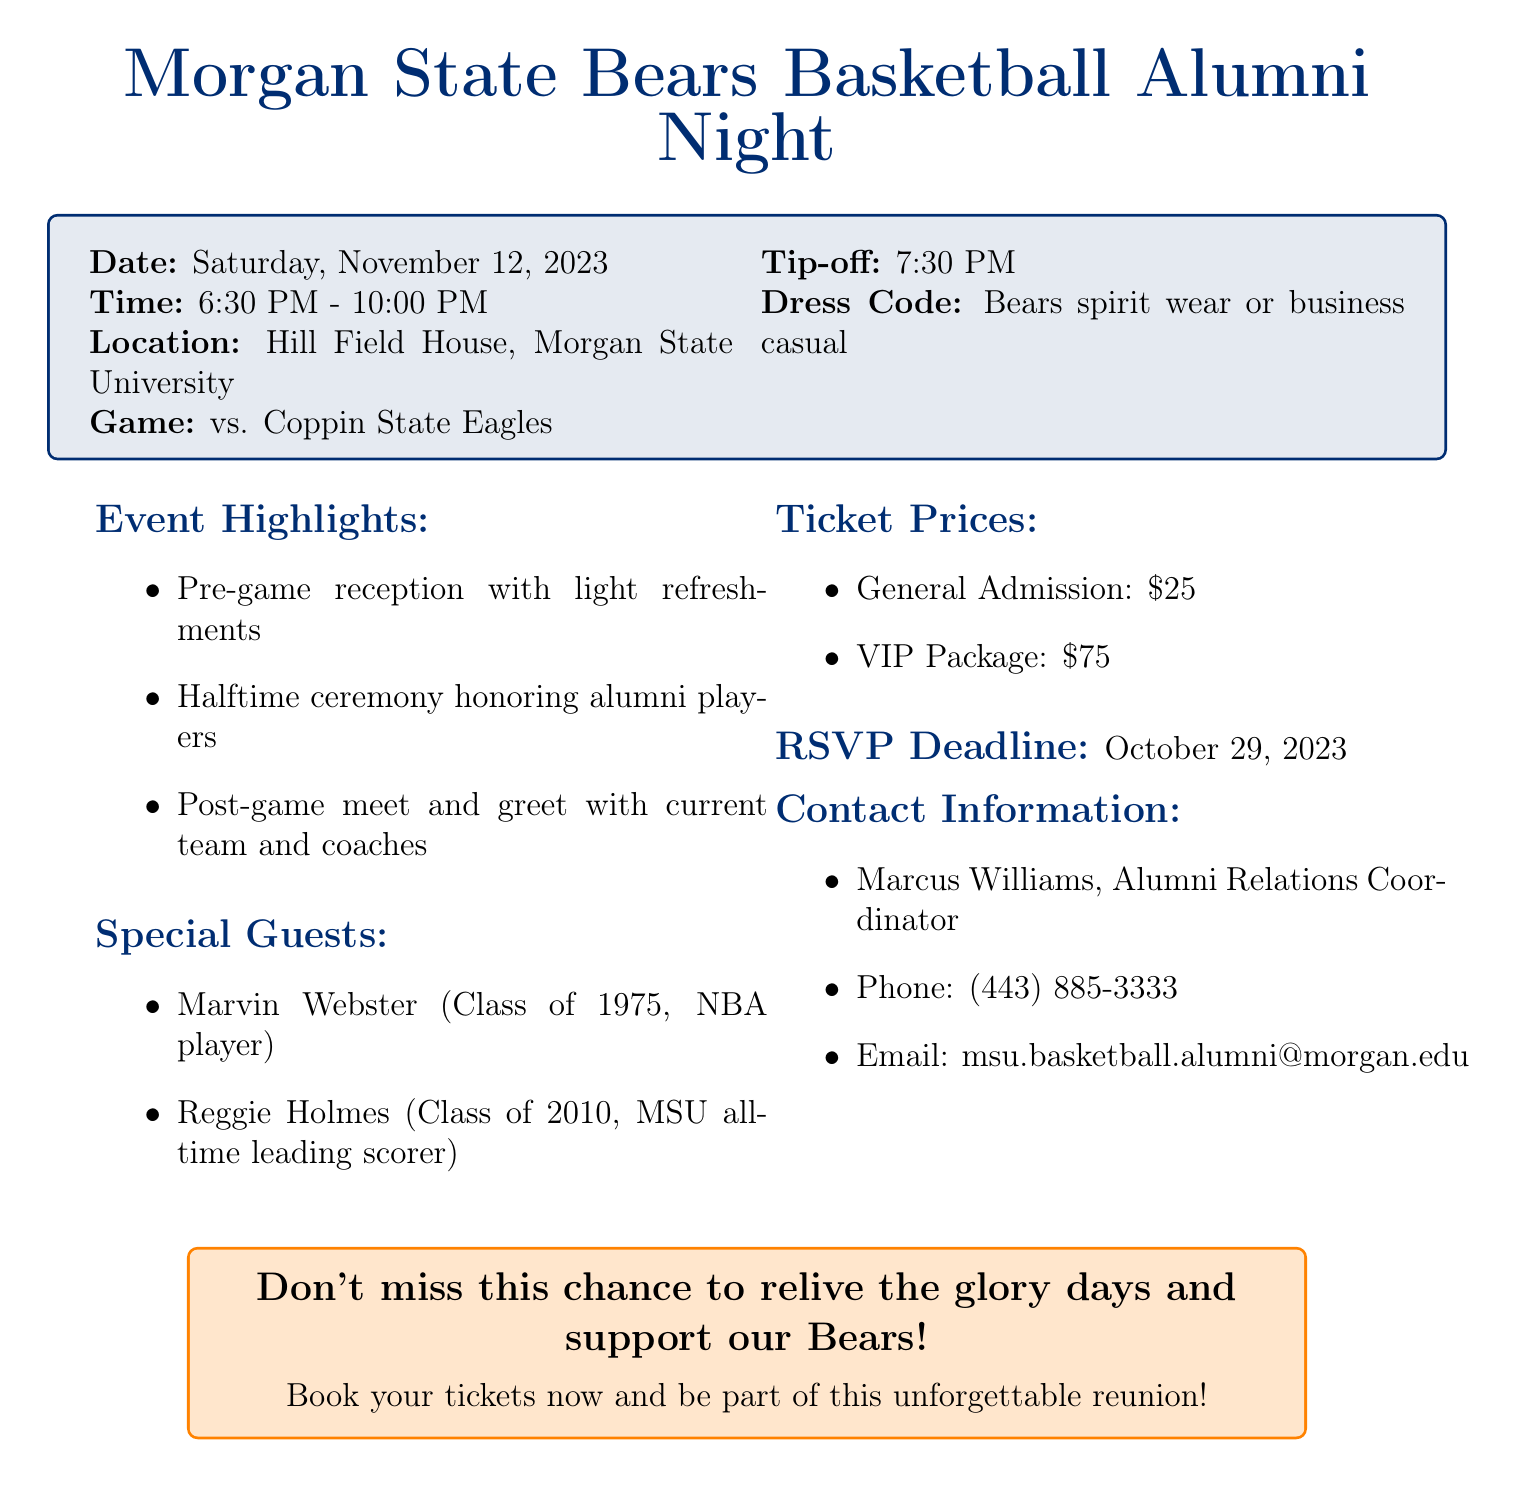What is the event name? The event name is clearly stated at the beginning of the document as the Morgan State Bears Basketball Alumni Night.
Answer: Morgan State Bears Basketball Alumni Night When is the event scheduled? The document specifies the date for the event, which is provided in a bold format.
Answer: Saturday, November 12, 2023 What time does the event start? The start time is listed distinctly in the document and is mentioned alongside the end time.
Answer: 6:30 PM What are the ticket prices for General Admission? The ticket prices are enumerated in the document, particularly highlighting General Admission.
Answer: $25 Who is one of the special guests attending? Special guests are listed in a separate section, and one example can be directly taken from there.
Answer: Marvin Webster What is the dress code for the event? The dress code is clearly noted in the document, specifying what attendees should wear.
Answer: Bears spirit wear or business casual What time is the game against Coppin State Eagles? The game details are provided, including the specific time of the tip-off.
Answer: 7:30 PM What is the RSVP deadline for the event? The deadline for RSVPing is distinctly mentioned towards the end of the document.
Answer: October 29, 2023 Who should be contacted for more information? The contact person is listed in the document along with the details necessary for outreach.
Answer: Marcus Williams 